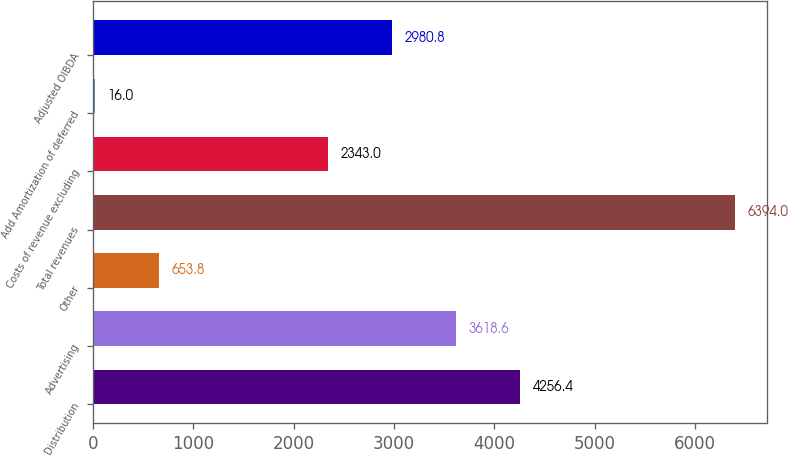Convert chart to OTSL. <chart><loc_0><loc_0><loc_500><loc_500><bar_chart><fcel>Distribution<fcel>Advertising<fcel>Other<fcel>Total revenues<fcel>Costs of revenue excluding<fcel>Add Amortization of deferred<fcel>Adjusted OIBDA<nl><fcel>4256.4<fcel>3618.6<fcel>653.8<fcel>6394<fcel>2343<fcel>16<fcel>2980.8<nl></chart> 